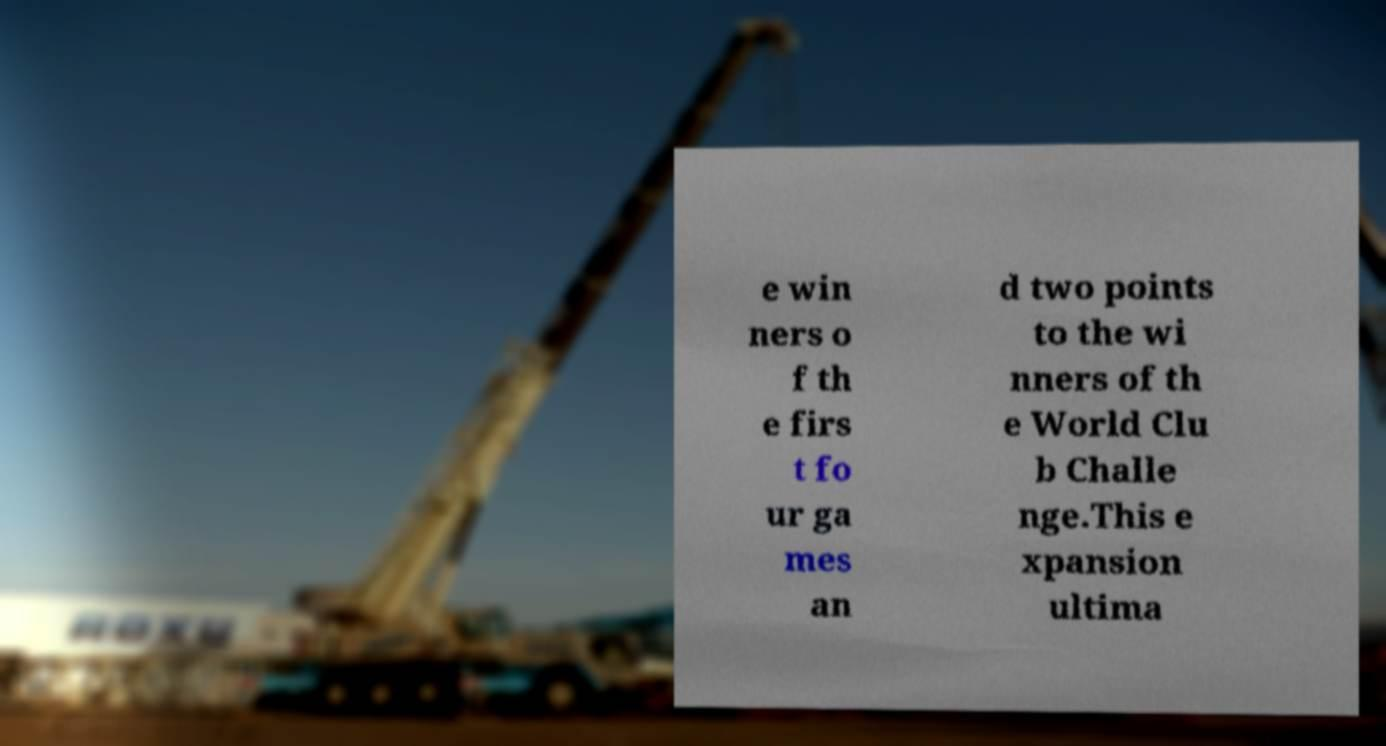For documentation purposes, I need the text within this image transcribed. Could you provide that? e win ners o f th e firs t fo ur ga mes an d two points to the wi nners of th e World Clu b Challe nge.This e xpansion ultima 